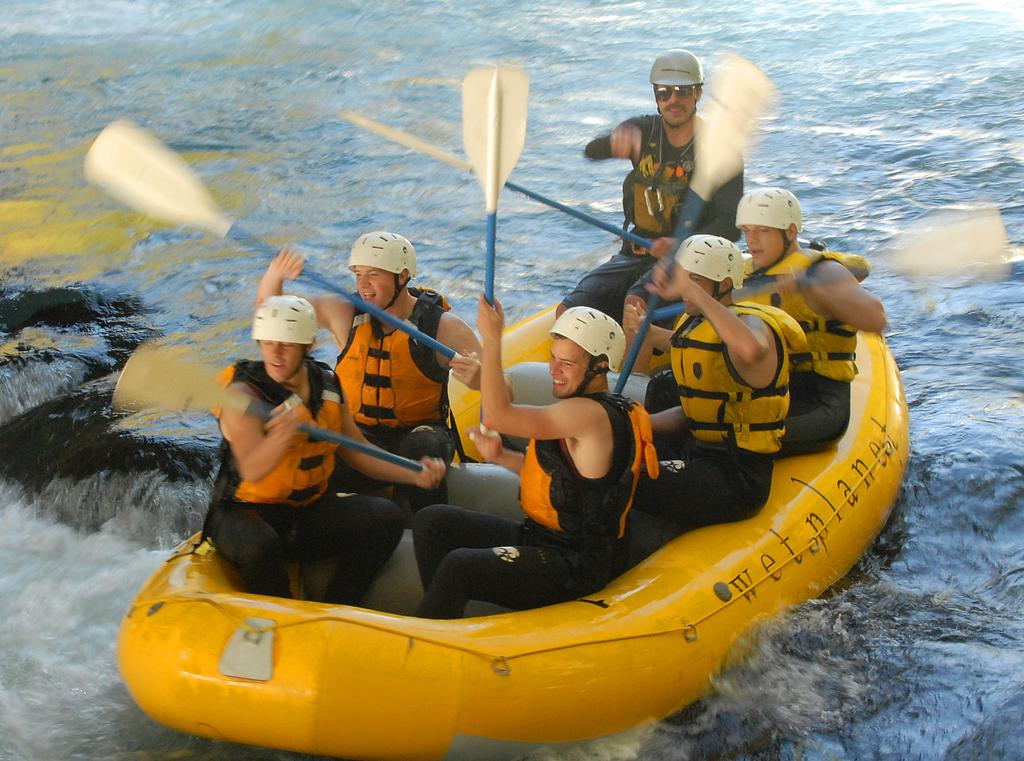Who or what can be seen in the image? There are people in the image. What are the people doing in the image? The people are sailing on an inflatable boat. Where is the boat located in the image? The boat is on a river. What type of unit is being used by the people to measure the depth of the river in the image? There is no indication in the image that the people are measuring the depth of the river or using any unit for that purpose. 